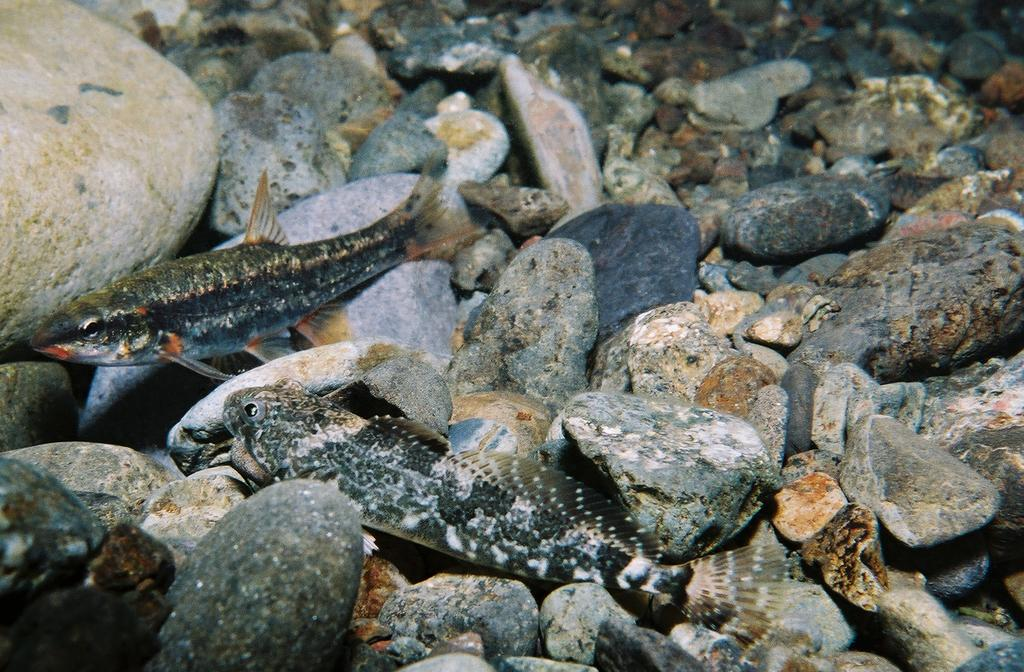What type of objects can be seen in the image? The image contains stones. Are there any living creatures visible in the image? Yes, there are two fishes present in the image. What type of tree can be seen in the image? There is no tree present in the image; it only contains stones and two fishes. 